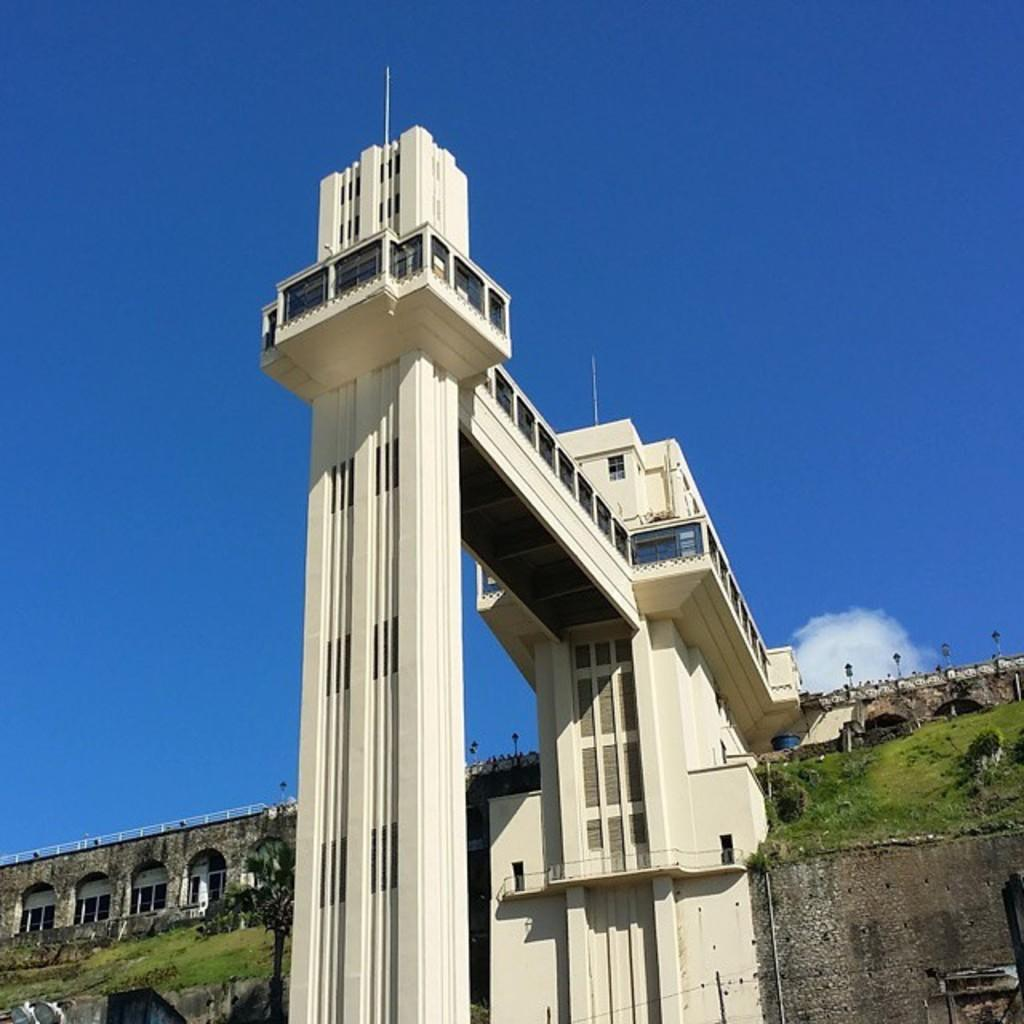What can be seen in the sky in the image? The sky with clouds is visible in the image. What is visible at ground level in the image? The ground is visible in the image. What is the main object in the image? There is a grill in the image. What architectural features can be seen in the image? Windows and pillars are present in the image. What infrastructure elements are visible in the image? Pipelines are visible in the image. What type of vegetation is present in the image? Trees are present in the image. What type of coat is the grill wearing in the image? The grill is not wearing a coat, as it is an inanimate object and does not have the ability to wear clothing. 